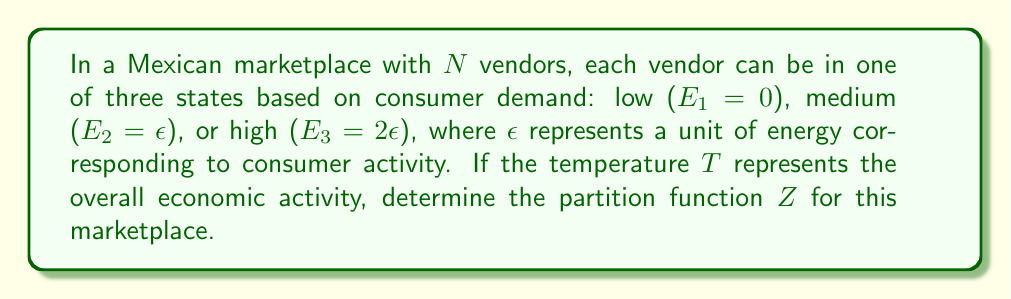Solve this math problem. To solve this problem, we'll follow these steps:

1) The partition function $Z$ for a system with discrete energy levels is given by:

   $$Z = \sum_i g_i e^{-\beta E_i}$$

   where $g_i$ is the degeneracy of energy level $E_i$, and $\beta = \frac{1}{k_B T}$.

2) In this case, we have three energy levels for each vendor:
   $E_1 = 0$, $E_2 = \epsilon$, and $E_3 = 2\epsilon$

3) Since each vendor can be in any of these three states independently, the total number of microstates (degeneracy) for each energy level is $3^N$.

4) Substituting into the partition function equation:

   $$Z = 3^N e^{-\beta \cdot 0} + 3^N e^{-\beta \epsilon} + 3^N e^{-\beta \cdot 2\epsilon}$$

5) Simplify:

   $$Z = 3^N (1 + e^{-\beta \epsilon} + e^{-2\beta \epsilon})$$

6) Substitute $\beta = \frac{1}{k_B T}$:

   $$Z = 3^N (1 + e^{-\epsilon/(k_B T)} + e^{-2\epsilon/(k_B T)})$$

This is the partition function for the marketplace with $N$ vendors and three levels of consumer demand.
Answer: $$Z = 3^N (1 + e^{-\epsilon/(k_B T)} + e^{-2\epsilon/(k_B T)})$$ 